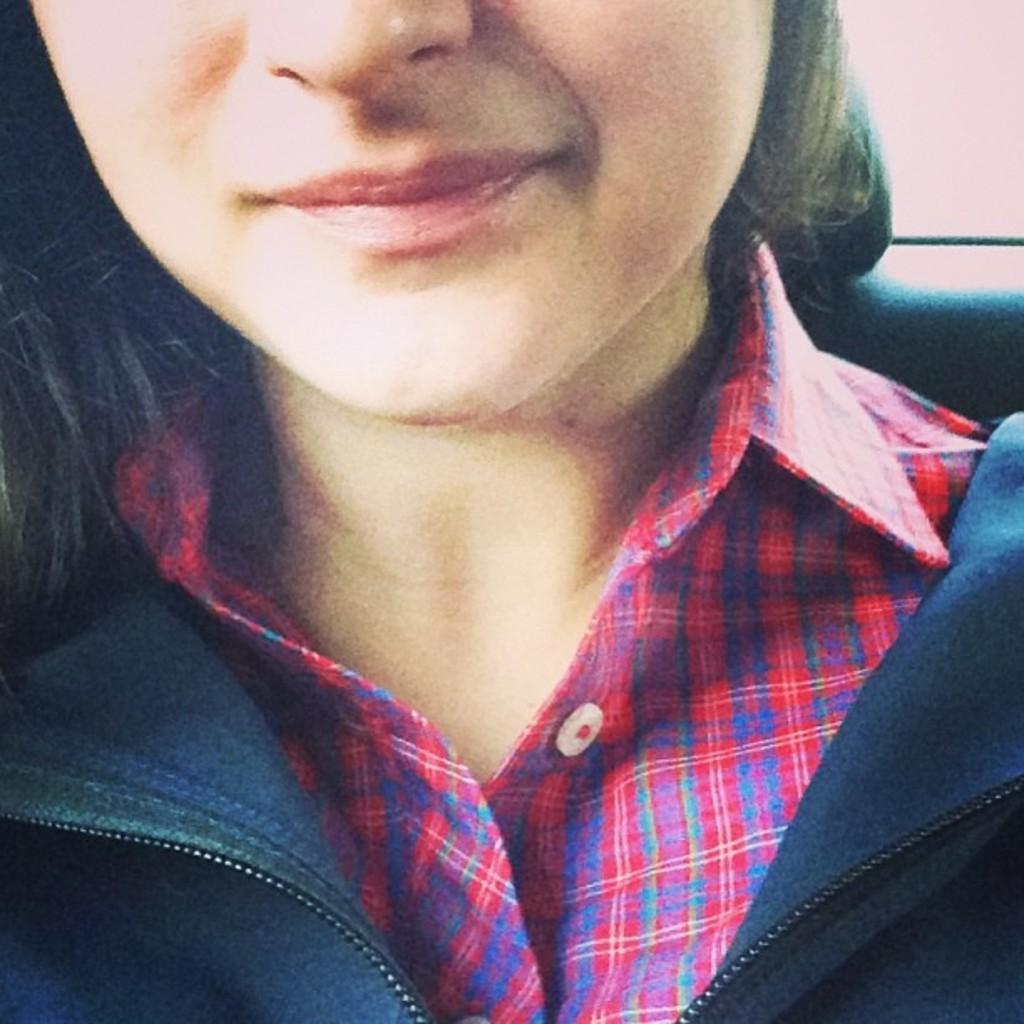In one or two sentences, can you explain what this image depicts? In this image we can see half face of a girl. She is wearing red color shirt and blue jacket. 